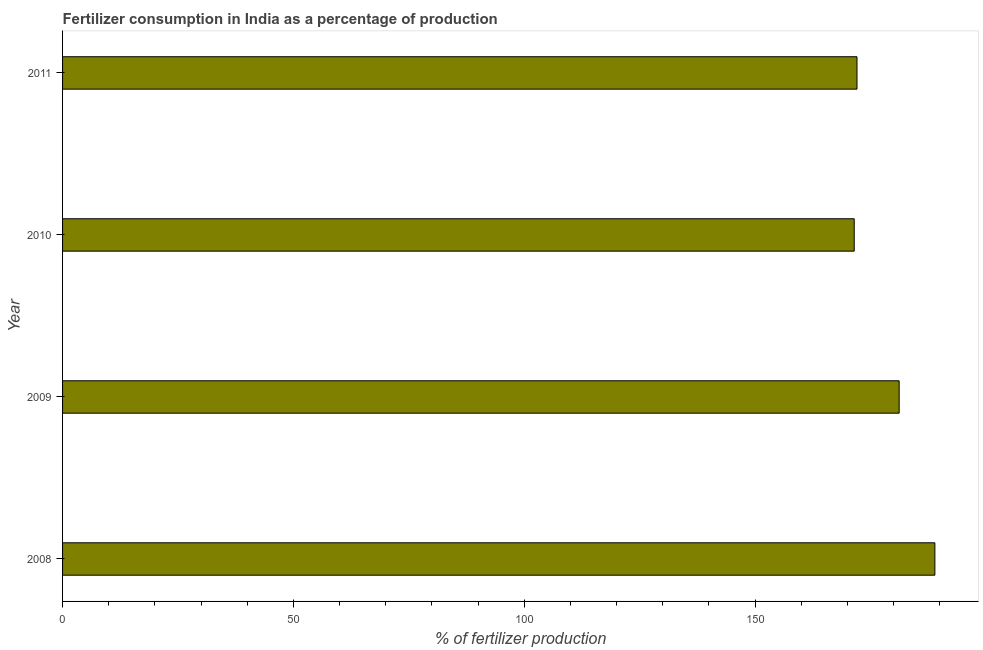Does the graph contain any zero values?
Keep it short and to the point. No. What is the title of the graph?
Give a very brief answer. Fertilizer consumption in India as a percentage of production. What is the label or title of the X-axis?
Give a very brief answer. % of fertilizer production. What is the amount of fertilizer consumption in 2010?
Provide a short and direct response. 171.49. Across all years, what is the maximum amount of fertilizer consumption?
Ensure brevity in your answer.  188.97. Across all years, what is the minimum amount of fertilizer consumption?
Make the answer very short. 171.49. In which year was the amount of fertilizer consumption maximum?
Make the answer very short. 2008. What is the sum of the amount of fertilizer consumption?
Offer a very short reply. 713.78. What is the difference between the amount of fertilizer consumption in 2008 and 2010?
Provide a succinct answer. 17.47. What is the average amount of fertilizer consumption per year?
Ensure brevity in your answer.  178.44. What is the median amount of fertilizer consumption?
Your answer should be very brief. 176.66. Do a majority of the years between 2009 and 2011 (inclusive) have amount of fertilizer consumption greater than 70 %?
Ensure brevity in your answer.  Yes. What is the ratio of the amount of fertilizer consumption in 2009 to that in 2010?
Give a very brief answer. 1.06. Is the amount of fertilizer consumption in 2008 less than that in 2011?
Ensure brevity in your answer.  No. Is the difference between the amount of fertilizer consumption in 2010 and 2011 greater than the difference between any two years?
Your response must be concise. No. What is the difference between the highest and the second highest amount of fertilizer consumption?
Provide a short and direct response. 7.73. What is the difference between the highest and the lowest amount of fertilizer consumption?
Keep it short and to the point. 17.47. How many bars are there?
Provide a short and direct response. 4. How many years are there in the graph?
Your answer should be very brief. 4. What is the difference between two consecutive major ticks on the X-axis?
Offer a very short reply. 50. What is the % of fertilizer production in 2008?
Provide a succinct answer. 188.97. What is the % of fertilizer production in 2009?
Your response must be concise. 181.23. What is the % of fertilizer production in 2010?
Make the answer very short. 171.49. What is the % of fertilizer production of 2011?
Your answer should be very brief. 172.09. What is the difference between the % of fertilizer production in 2008 and 2009?
Provide a short and direct response. 7.73. What is the difference between the % of fertilizer production in 2008 and 2010?
Offer a terse response. 17.47. What is the difference between the % of fertilizer production in 2008 and 2011?
Give a very brief answer. 16.87. What is the difference between the % of fertilizer production in 2009 and 2010?
Ensure brevity in your answer.  9.74. What is the difference between the % of fertilizer production in 2009 and 2011?
Offer a very short reply. 9.14. What is the difference between the % of fertilizer production in 2010 and 2011?
Offer a very short reply. -0.6. What is the ratio of the % of fertilizer production in 2008 to that in 2009?
Your answer should be very brief. 1.04. What is the ratio of the % of fertilizer production in 2008 to that in 2010?
Provide a succinct answer. 1.1. What is the ratio of the % of fertilizer production in 2008 to that in 2011?
Ensure brevity in your answer.  1.1. What is the ratio of the % of fertilizer production in 2009 to that in 2010?
Ensure brevity in your answer.  1.06. What is the ratio of the % of fertilizer production in 2009 to that in 2011?
Make the answer very short. 1.05. What is the ratio of the % of fertilizer production in 2010 to that in 2011?
Your response must be concise. 1. 